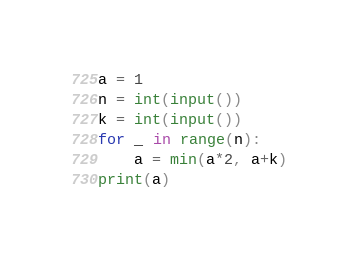Convert code to text. <code><loc_0><loc_0><loc_500><loc_500><_Python_>a = 1
n = int(input())
k = int(input())
for _ in range(n):
    a = min(a*2, a+k)
print(a)</code> 